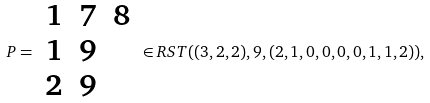Convert formula to latex. <formula><loc_0><loc_0><loc_500><loc_500>P = \begin{array} { c c c } 1 & 7 & 8 \\ 1 & 9 & \\ 2 & 9 & \end{array} \in R S T ( ( 3 , 2 , 2 ) , 9 , ( 2 , 1 , 0 , 0 , 0 , 0 , 1 , 1 , 2 ) ) ,</formula> 